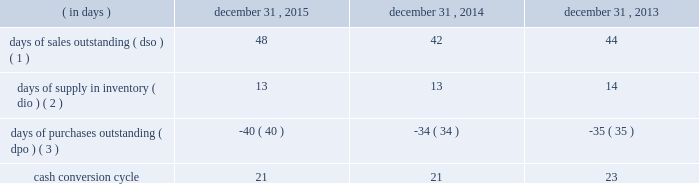Table of contents ( 4 ) the decline in cash flows was driven by the timing of inventory purchases at the end of 2014 versus 2013 .
In order to manage our working capital and operating cash needs , we monitor our cash conversion cycle , defined as days of sales outstanding in accounts receivable plus days of supply in inventory minus days of purchases outstanding in accounts payable , based on a rolling three-month average .
Components of our cash conversion cycle are as follows: .
( 1 ) represents the rolling three-month average of the balance of trade accounts receivable , net at the end of the period divided by average daily net sales for the same three-month period .
Also incorporates components of other miscellaneous receivables .
( 2 ) represents the rolling three-month average of the balance of merchandise inventory at the end of the period divided by average daily cost of goods sold for the same three-month period .
( 3 ) represents the rolling three-month average of the combined balance of accounts payable-trade , excluding cash overdrafts , and accounts payable-inventory financing at the end of the period divided by average daily cost of goods sold for the same three-month period .
The cash conversion cycle remained at 21 days at december 31 , 2015 and december 31 , 2014 .
The increase in dso was primarily driven by a higher accounts receivable balance at december 31 , 2015 driven by higher public segment sales where customers generally take longer to pay than customers in our corporate segment , slower government payments in certain states due to budget issues and an increase in net sales and related accounts receivable for third-party services such as software assurance and warranties .
These services have an unfavorable impact on dso as the receivable is recognized on the balance sheet on a gross basis while the corresponding sales amount in the statement of operations is recorded on a net basis .
These services have a favorable impact on dpo as the payable is recognized on the balance sheet without a corresponding cost of sale in the statement of operations because the cost paid to the vendor or third-party service provider is recorded as a reduction to net sales .
In addition to the impact of these services on dpo , dpo also increased due to the mix of payables with certain vendors that have longer payment terms .
The cash conversion cycle decreased to 21 days at december 31 , 2014 compared to 23 days at december 31 , 2013 , primarily driven by improvement in dso .
The decline in dso was primarily driven by improved collections and early payments from certain customers .
Additionally , the timing of inventory receipts at the end of 2014 had a favorable impact on dio and an unfavorable impact on dpo .
Investing activities net cash used in investing activities increased $ 189.6 million in 2015 compared to 2014 .
The increase was primarily due to the completion of the acquisition of kelway by purchasing the remaining 65% ( 65 % ) of its outstanding common stock on august 1 , 2015 .
Additionally , capital expenditures increased $ 35.1 million to $ 90.1 million from $ 55.0 million for 2015 and 2014 , respectively , primarily for our new office location and an increase in spending related to improvements to our information technology systems .
Net cash used in investing activities increased $ 117.7 million in 2014 compared to 2013 .
We paid $ 86.8 million in the fourth quarter of 2014 to acquire a 35% ( 35 % ) non-controlling interest in kelway .
Additionally , capital expenditures increased $ 7.9 million to $ 55.0 million from $ 47.1 million in 2014 and 2013 , respectively , primarily for improvements to our information technology systems during both years .
Financing activities net cash used in financing activities increased $ 114.5 million in 2015 compared to 2014 .
The increase was primarily driven by share repurchases during the year ended december 31 , 2015 which resulted in an increase in cash used for financing activities of $ 241.3 million .
For more information on our share repurchase program , see item 5 , 201cmarket for registrant 2019s common equity , related stockholder matters and issuer purchases of equity securities . 201d the increase was partially offset by the changes in accounts payable-inventory financing , which resulted in an increase in cash provided for financing activities of $ 20.4 million , and the net impact of our debt transactions which resulted in cash outflows of $ 7.1 million and $ 145.9 million during the years .
What was the approximate value of kelway in the fourth quarter of 2014 , in millions? 
Computations: ((100 / 35) * 86.8)
Answer: 248.0. Table of contents ( 4 ) the decline in cash flows was driven by the timing of inventory purchases at the end of 2014 versus 2013 .
In order to manage our working capital and operating cash needs , we monitor our cash conversion cycle , defined as days of sales outstanding in accounts receivable plus days of supply in inventory minus days of purchases outstanding in accounts payable , based on a rolling three-month average .
Components of our cash conversion cycle are as follows: .
( 1 ) represents the rolling three-month average of the balance of trade accounts receivable , net at the end of the period divided by average daily net sales for the same three-month period .
Also incorporates components of other miscellaneous receivables .
( 2 ) represents the rolling three-month average of the balance of merchandise inventory at the end of the period divided by average daily cost of goods sold for the same three-month period .
( 3 ) represents the rolling three-month average of the combined balance of accounts payable-trade , excluding cash overdrafts , and accounts payable-inventory financing at the end of the period divided by average daily cost of goods sold for the same three-month period .
The cash conversion cycle remained at 21 days at december 31 , 2015 and december 31 , 2014 .
The increase in dso was primarily driven by a higher accounts receivable balance at december 31 , 2015 driven by higher public segment sales where customers generally take longer to pay than customers in our corporate segment , slower government payments in certain states due to budget issues and an increase in net sales and related accounts receivable for third-party services such as software assurance and warranties .
These services have an unfavorable impact on dso as the receivable is recognized on the balance sheet on a gross basis while the corresponding sales amount in the statement of operations is recorded on a net basis .
These services have a favorable impact on dpo as the payable is recognized on the balance sheet without a corresponding cost of sale in the statement of operations because the cost paid to the vendor or third-party service provider is recorded as a reduction to net sales .
In addition to the impact of these services on dpo , dpo also increased due to the mix of payables with certain vendors that have longer payment terms .
The cash conversion cycle decreased to 21 days at december 31 , 2014 compared to 23 days at december 31 , 2013 , primarily driven by improvement in dso .
The decline in dso was primarily driven by improved collections and early payments from certain customers .
Additionally , the timing of inventory receipts at the end of 2014 had a favorable impact on dio and an unfavorable impact on dpo .
Investing activities net cash used in investing activities increased $ 189.6 million in 2015 compared to 2014 .
The increase was primarily due to the completion of the acquisition of kelway by purchasing the remaining 65% ( 65 % ) of its outstanding common stock on august 1 , 2015 .
Additionally , capital expenditures increased $ 35.1 million to $ 90.1 million from $ 55.0 million for 2015 and 2014 , respectively , primarily for our new office location and an increase in spending related to improvements to our information technology systems .
Net cash used in investing activities increased $ 117.7 million in 2014 compared to 2013 .
We paid $ 86.8 million in the fourth quarter of 2014 to acquire a 35% ( 35 % ) non-controlling interest in kelway .
Additionally , capital expenditures increased $ 7.9 million to $ 55.0 million from $ 47.1 million in 2014 and 2013 , respectively , primarily for improvements to our information technology systems during both years .
Financing activities net cash used in financing activities increased $ 114.5 million in 2015 compared to 2014 .
The increase was primarily driven by share repurchases during the year ended december 31 , 2015 which resulted in an increase in cash used for financing activities of $ 241.3 million .
For more information on our share repurchase program , see item 5 , 201cmarket for registrant 2019s common equity , related stockholder matters and issuer purchases of equity securities . 201d the increase was partially offset by the changes in accounts payable-inventory financing , which resulted in an increase in cash provided for financing activities of $ 20.4 million , and the net impact of our debt transactions which resulted in cash outflows of $ 7.1 million and $ 145.9 million during the years .
From dec 31 , 2013 to dec 31 , 2014 , what was the percentage decrease in the length of the cash conversion cycle? 
Computations: (((23 - 21) / 21) * 100)
Answer: 9.52381. 